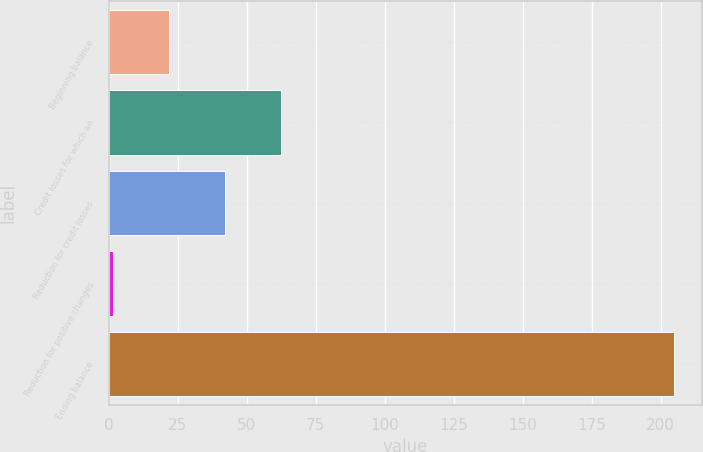Convert chart. <chart><loc_0><loc_0><loc_500><loc_500><bar_chart><fcel>Beginning balance<fcel>Credit losses for which an<fcel>Reduction for credit losses<fcel>Reduction for positive changes<fcel>Ending balance<nl><fcel>21.91<fcel>62.53<fcel>42.22<fcel>1.6<fcel>204.7<nl></chart> 